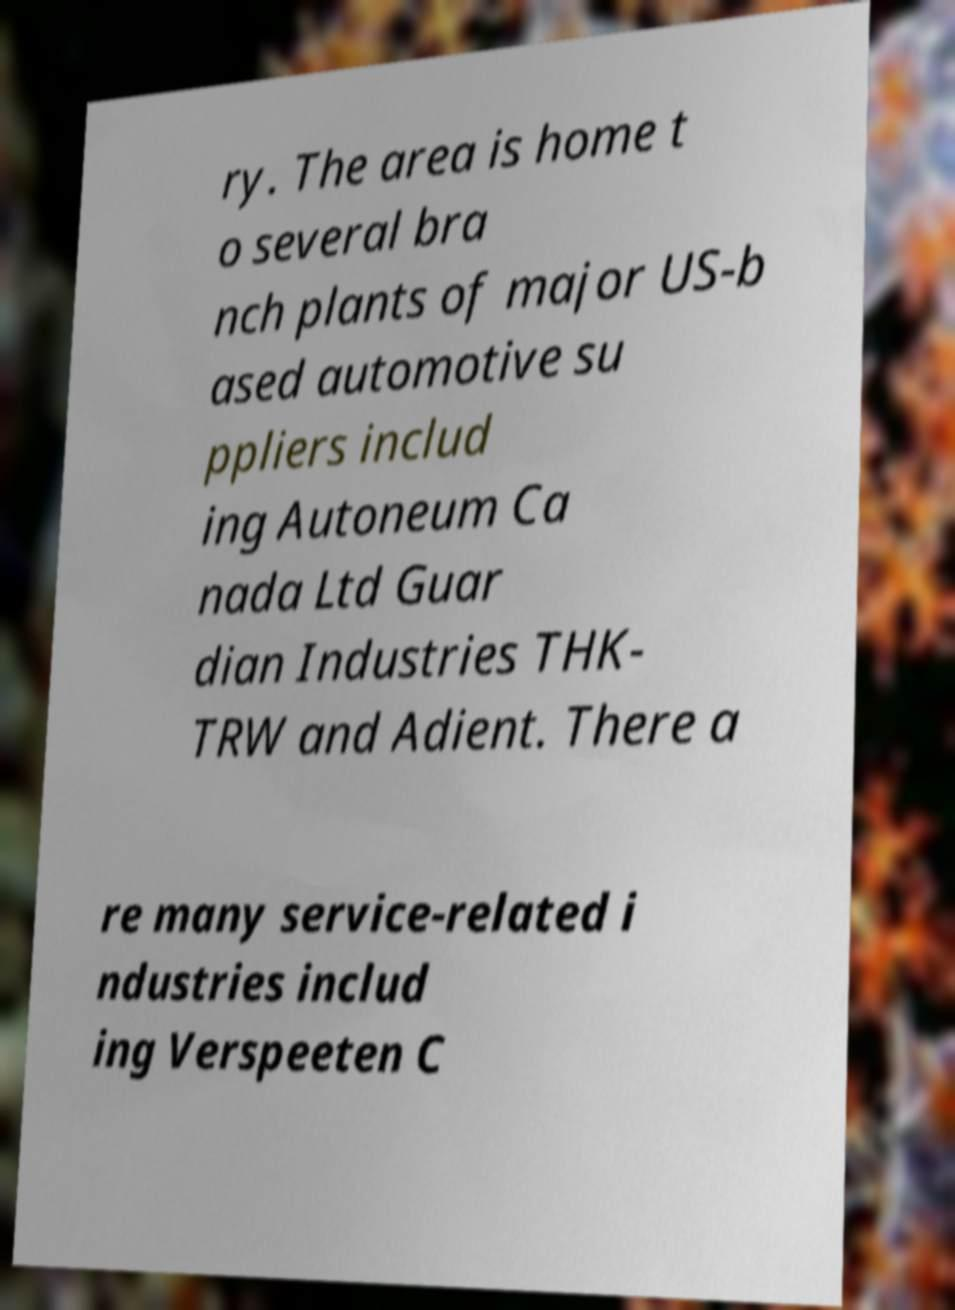I need the written content from this picture converted into text. Can you do that? ry. The area is home t o several bra nch plants of major US-b ased automotive su ppliers includ ing Autoneum Ca nada Ltd Guar dian Industries THK- TRW and Adient. There a re many service-related i ndustries includ ing Verspeeten C 